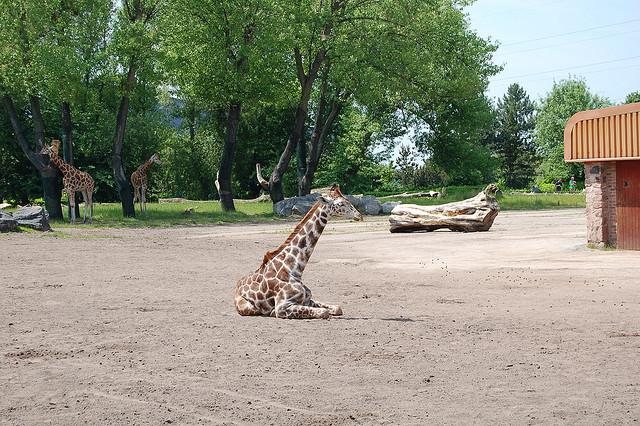What animal is in this picture?
Be succinct. Giraffe. What color is the building?
Keep it brief. Brown. Is the weather hot?
Answer briefly. Yes. 